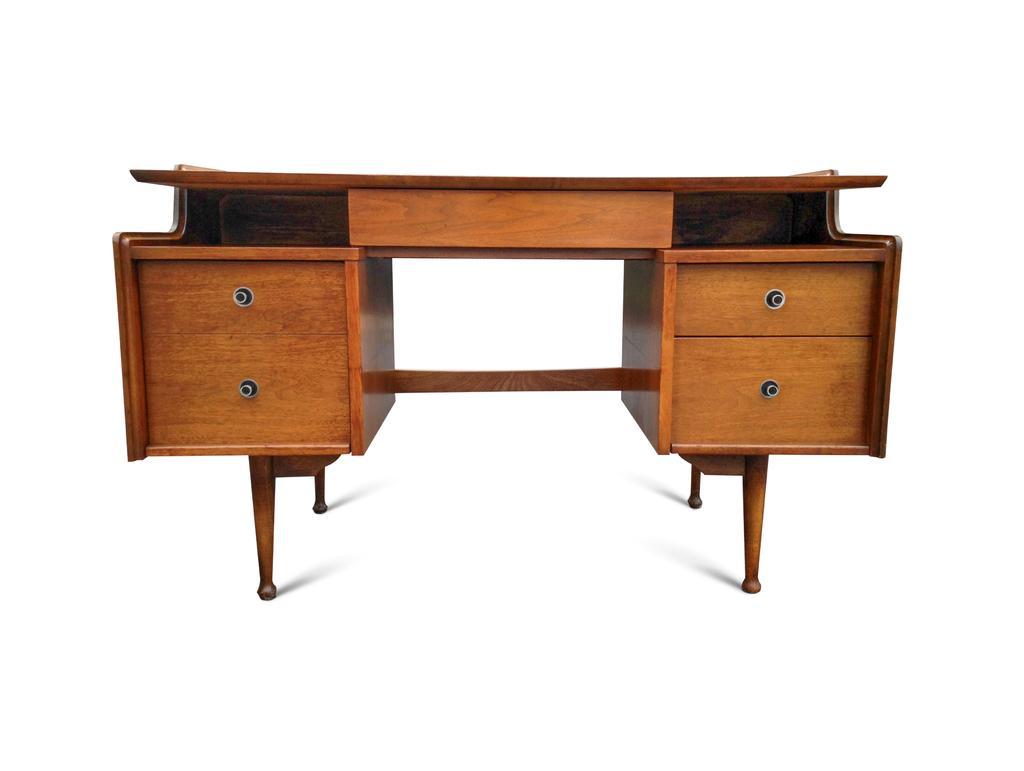In one or two sentences, can you explain what this image depicts? In this picture we can see a wooden writing desk, there are four drawers here, we can see a white color background. 